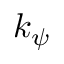<formula> <loc_0><loc_0><loc_500><loc_500>k _ { \psi }</formula> 